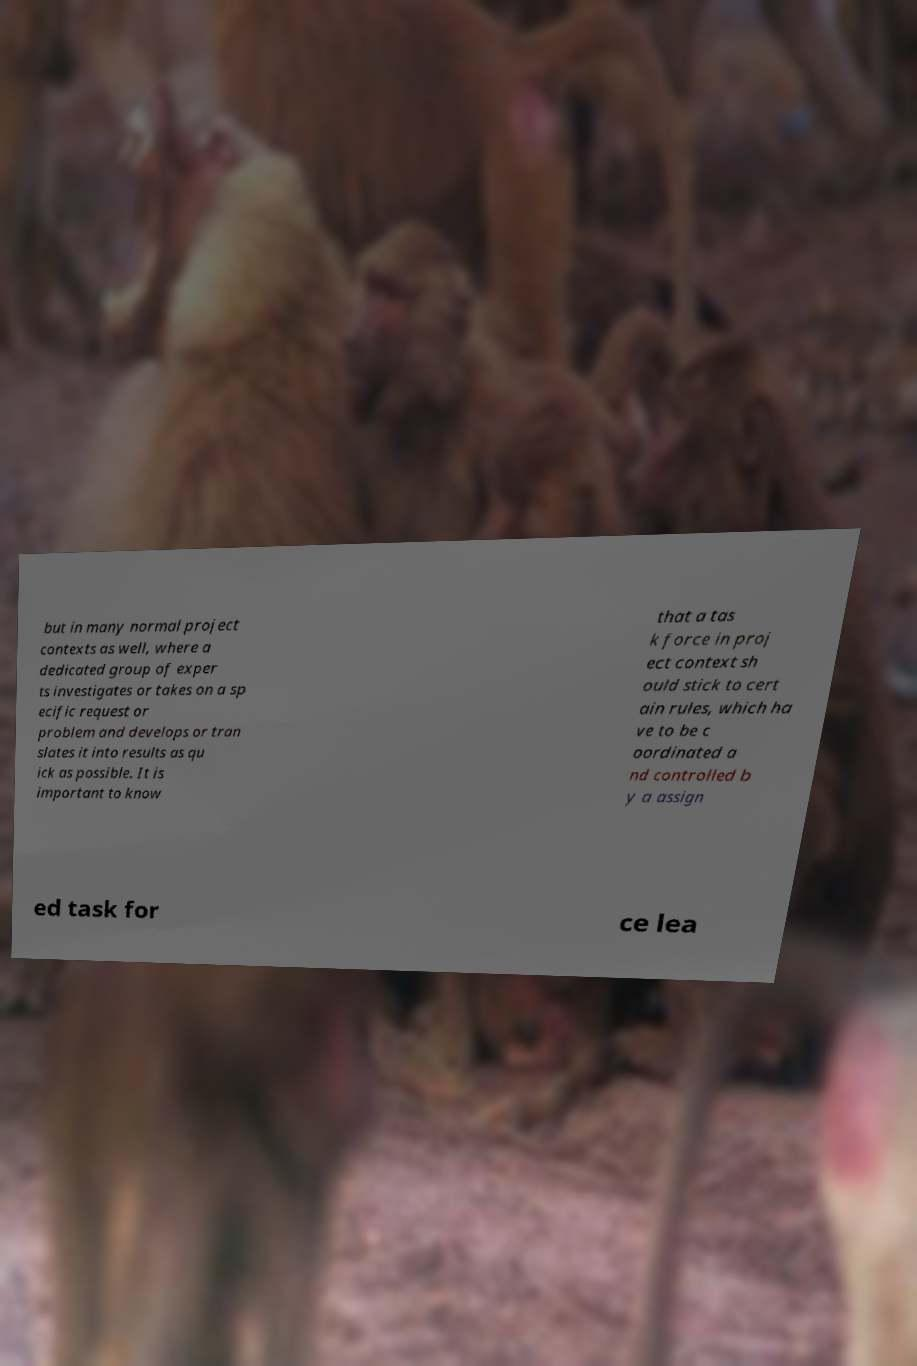Please read and relay the text visible in this image. What does it say? but in many normal project contexts as well, where a dedicated group of exper ts investigates or takes on a sp ecific request or problem and develops or tran slates it into results as qu ick as possible. It is important to know that a tas k force in proj ect context sh ould stick to cert ain rules, which ha ve to be c oordinated a nd controlled b y a assign ed task for ce lea 